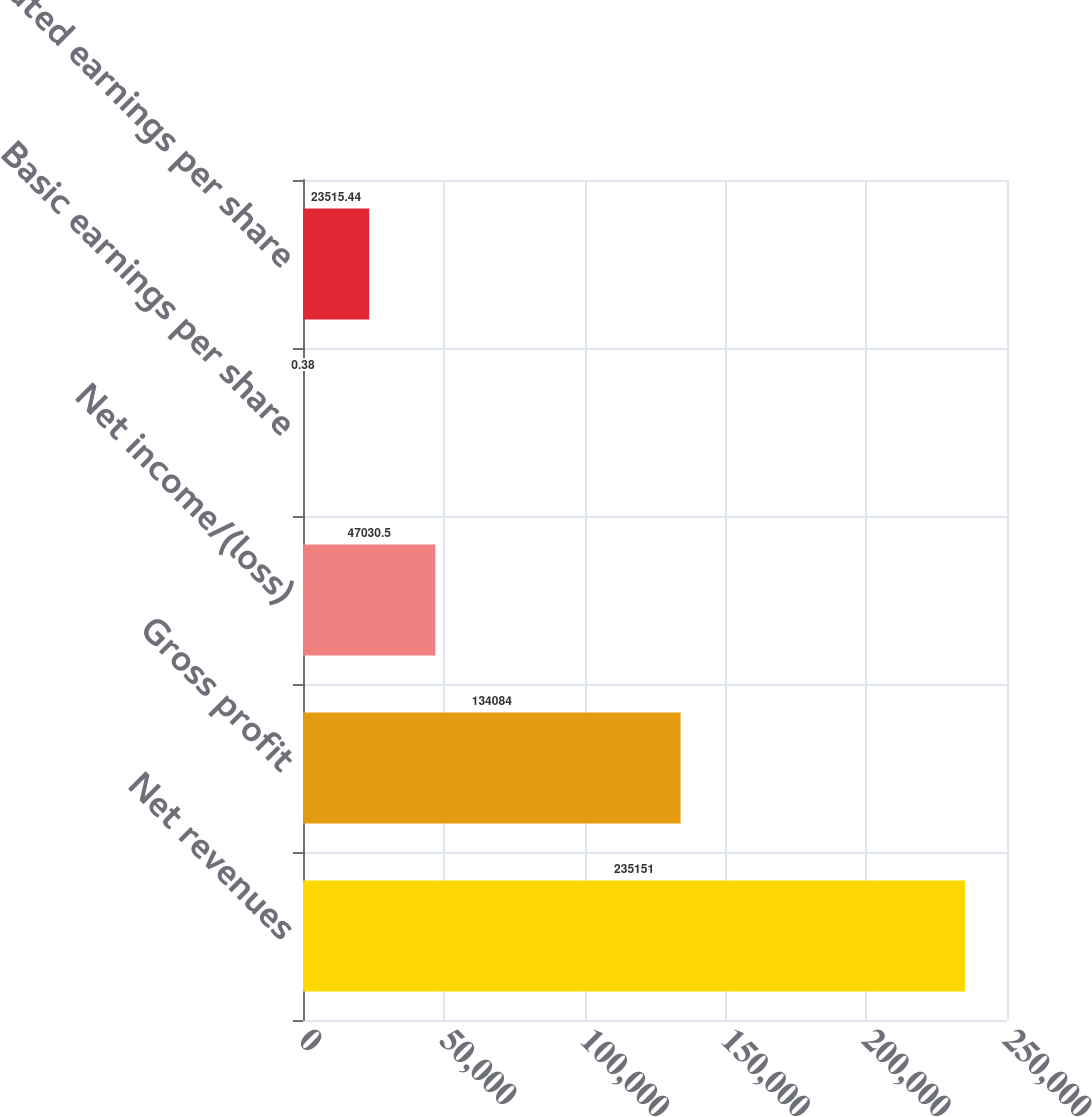Convert chart to OTSL. <chart><loc_0><loc_0><loc_500><loc_500><bar_chart><fcel>Net revenues<fcel>Gross profit<fcel>Net income/(loss)<fcel>Basic earnings per share<fcel>Diluted earnings per share<nl><fcel>235151<fcel>134084<fcel>47030.5<fcel>0.38<fcel>23515.4<nl></chart> 